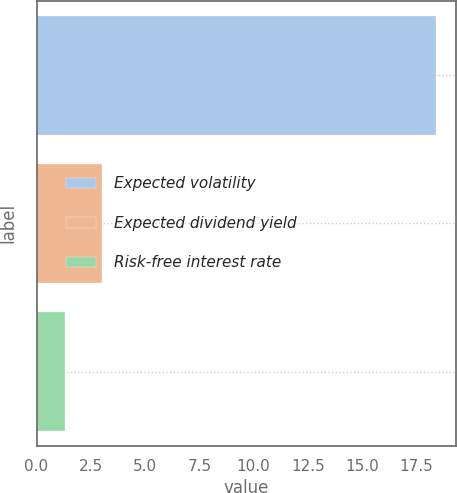Convert chart. <chart><loc_0><loc_0><loc_500><loc_500><bar_chart><fcel>Expected volatility<fcel>Expected dividend yield<fcel>Risk-free interest rate<nl><fcel>18.4<fcel>3.01<fcel>1.3<nl></chart> 